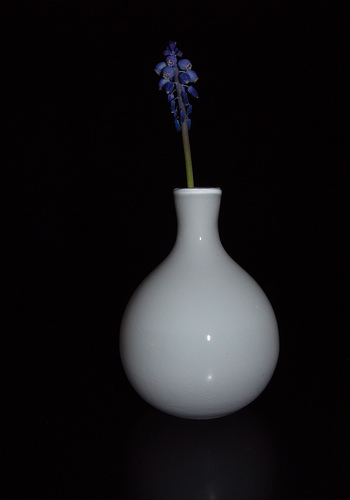<image>What time of day was this picture taken? It is unknown what time of day this picture was taken. It could be evening or night. What time of day was this picture taken? I don't know what time of day this picture was taken. It can be either midnight, evening or night. 